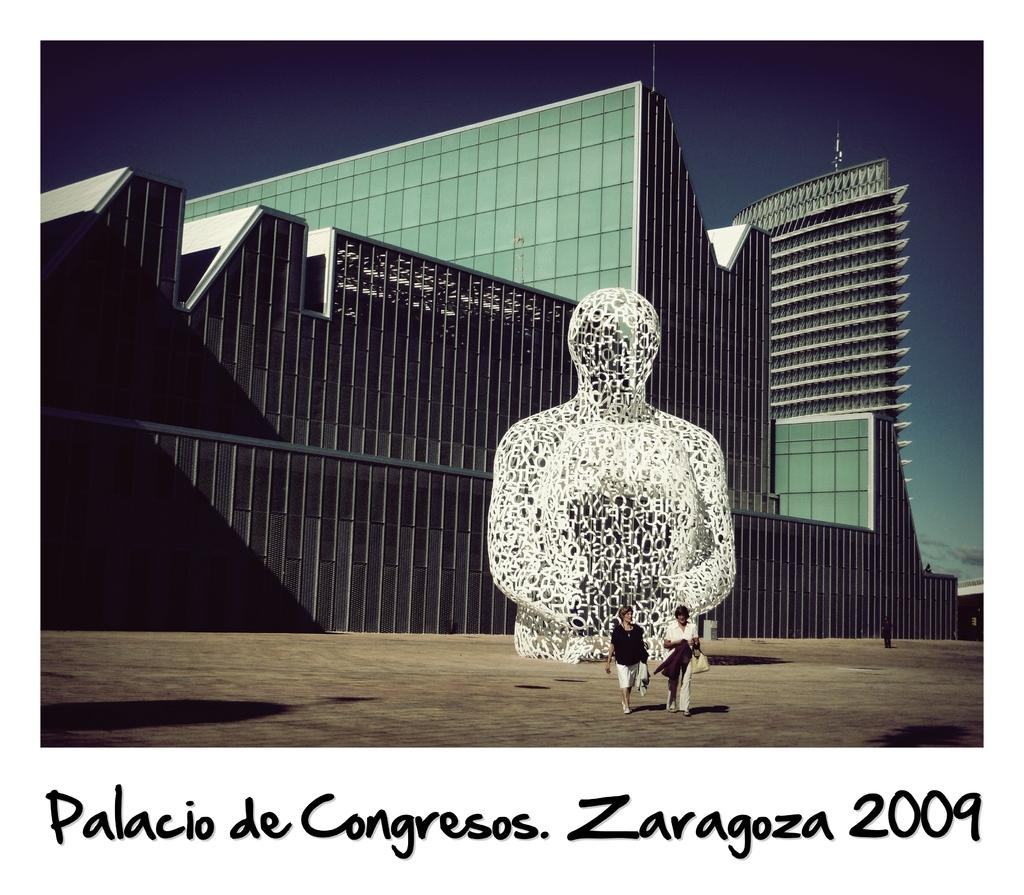Provide a one-sentence caption for the provided image. Two people walk in front of a huge wire statue of a figure on a postcard for a congress meeting in Zaragoza in 2009. 